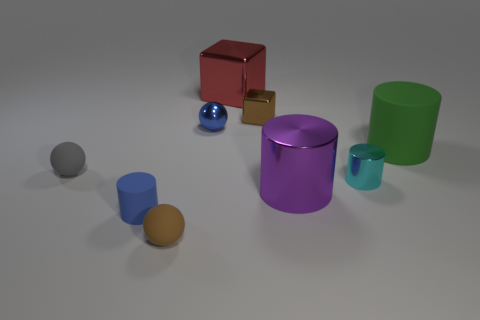Subtract all small matte spheres. How many spheres are left? 1 Subtract all brown cubes. How many cubes are left? 1 Subtract 1 cylinders. How many cylinders are left? 3 Subtract all blocks. How many objects are left? 7 Subtract all large brown shiny balls. Subtract all shiny cylinders. How many objects are left? 7 Add 9 metallic spheres. How many metallic spheres are left? 10 Add 3 purple spheres. How many purple spheres exist? 3 Subtract 1 green cylinders. How many objects are left? 8 Subtract all red balls. Subtract all gray blocks. How many balls are left? 3 